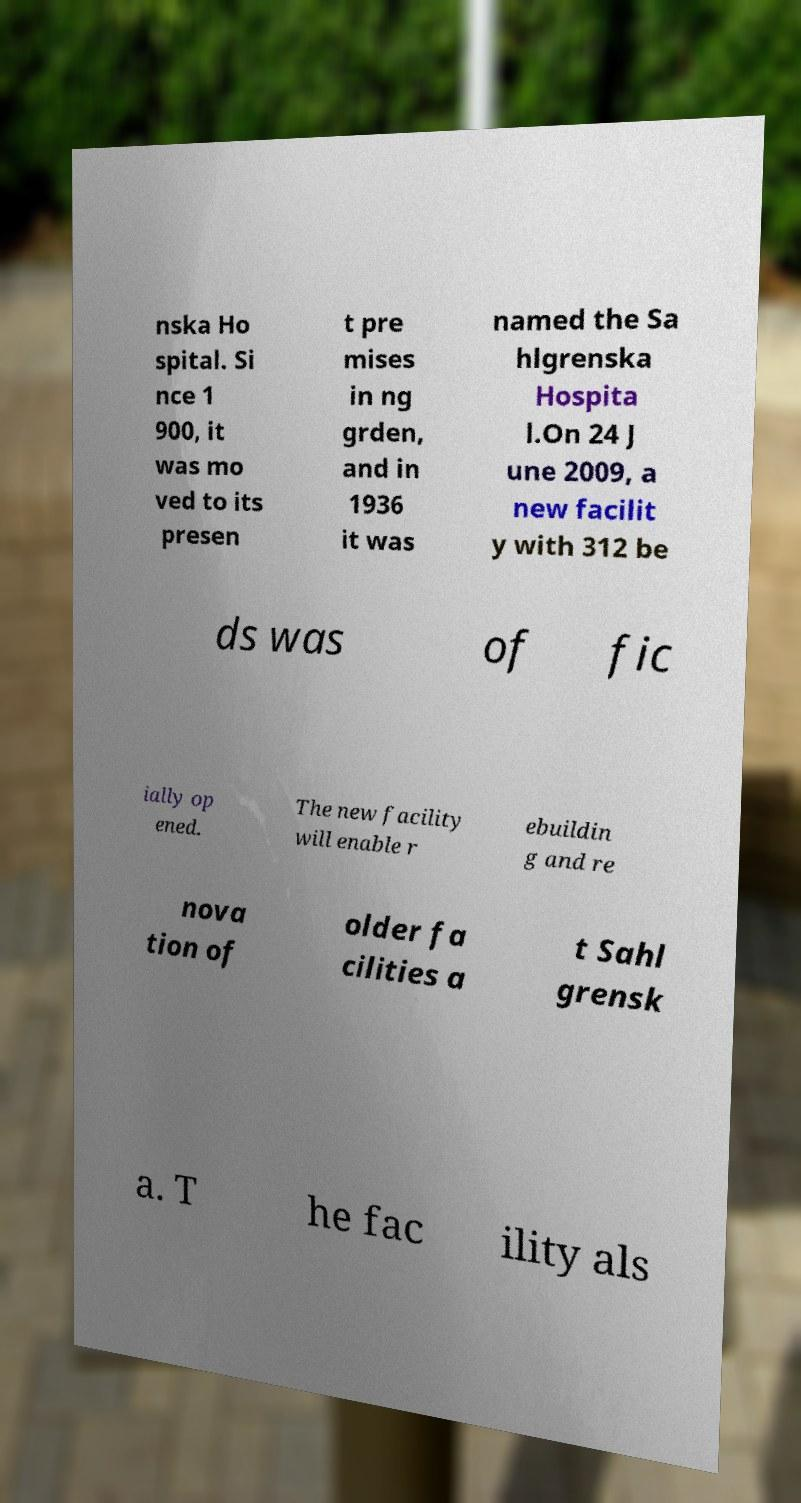Could you assist in decoding the text presented in this image and type it out clearly? nska Ho spital. Si nce 1 900, it was mo ved to its presen t pre mises in ng grden, and in 1936 it was named the Sa hlgrenska Hospita l.On 24 J une 2009, a new facilit y with 312 be ds was of fic ially op ened. The new facility will enable r ebuildin g and re nova tion of older fa cilities a t Sahl grensk a. T he fac ility als 